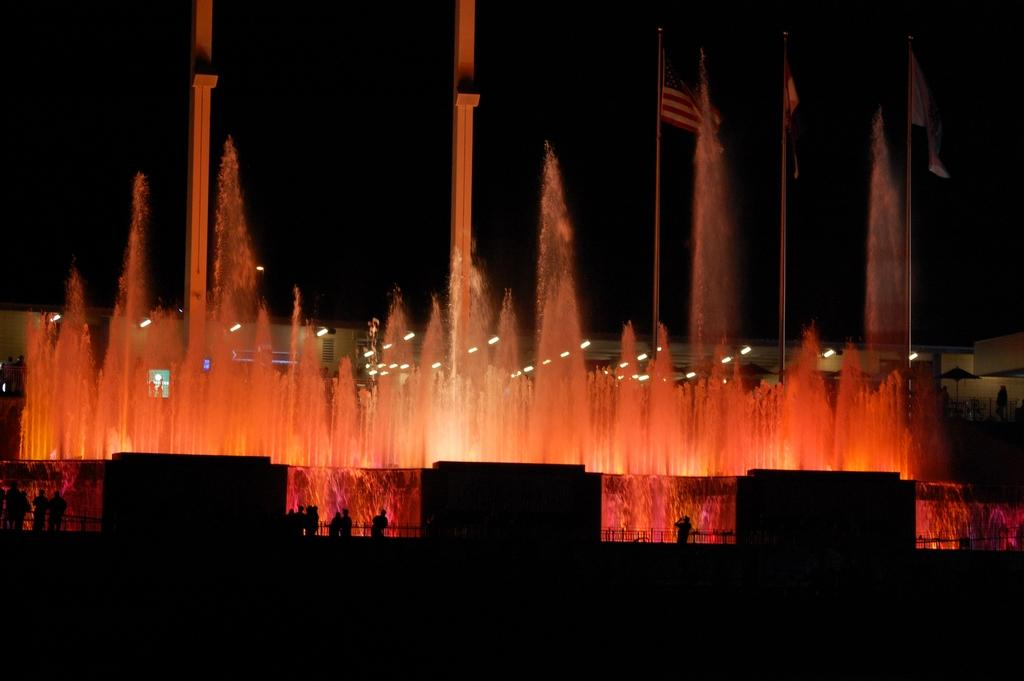What can be seen in the image that represents a country or organization? There are flags in the image that represent a country or organization. What is a prominent feature in the image that might be used for decoration or entertainment? There is a fountain in the image that can be used for decoration or entertainment. What are the people in the image doing? The people in the image are standing on the surface. What type of barrier is present in the image? There is a metal grill fence in the image. What can be seen in the image that provides illumination? There are lights in the image that provide illumination. How many boats are visible in the image? There are no boats present in the image. What type of chair is being used by the people in the image? There are no chairs visible in the image; the people are standing on the surface. 